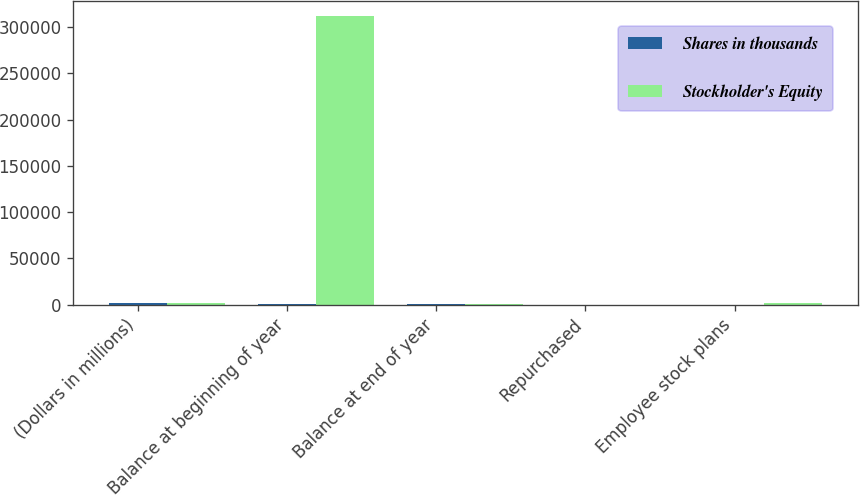Convert chart. <chart><loc_0><loc_0><loc_500><loc_500><stacked_bar_chart><ecel><fcel>(Dollars in millions)<fcel>Balance at beginning of year<fcel>Balance at end of year<fcel>Repurchased<fcel>Employee stock plans<nl><fcel>Shares in thousands<fcel>2004<fcel>312<fcel>347<fcel>4<fcel>49<nl><fcel>Stockholder's Equity<fcel>2004<fcel>312166<fcel>347<fcel>124<fcel>1838<nl></chart> 